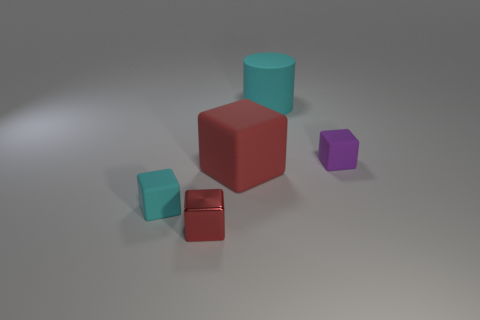Subtract all tiny red cubes. How many cubes are left? 3 Subtract all cubes. How many objects are left? 1 Subtract all purple cubes. How many cubes are left? 3 Subtract all gray cylinders. How many brown blocks are left? 0 Add 2 large blue metallic objects. How many objects exist? 7 Subtract 0 blue cylinders. How many objects are left? 5 Subtract 1 blocks. How many blocks are left? 3 Subtract all brown blocks. Subtract all brown cylinders. How many blocks are left? 4 Subtract all purple cubes. Subtract all metallic objects. How many objects are left? 3 Add 4 small purple things. How many small purple things are left? 5 